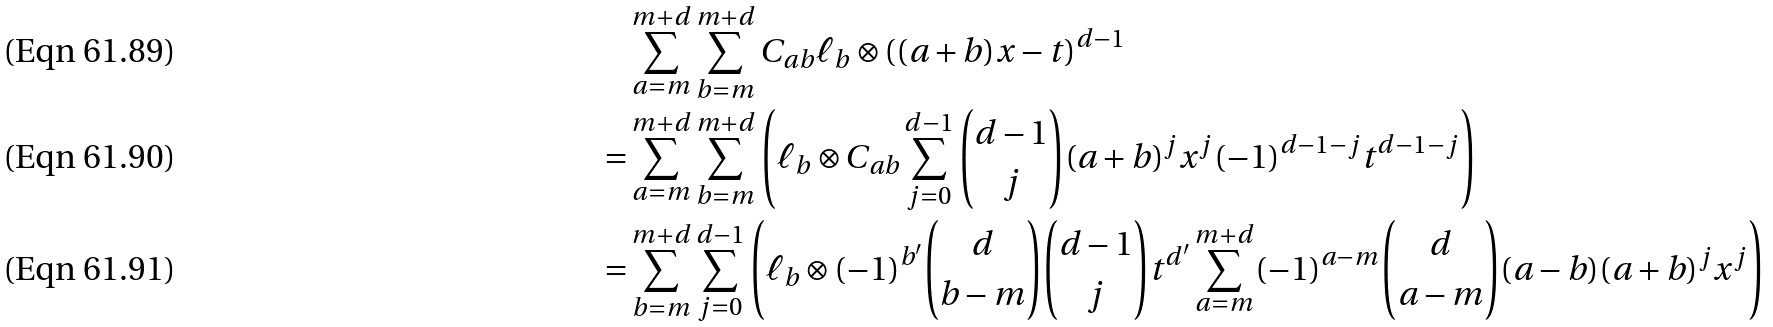Convert formula to latex. <formula><loc_0><loc_0><loc_500><loc_500>& \sum _ { a = m } ^ { m + d } \sum _ { b = m } ^ { m + d } C _ { a b } \ell _ { b } \otimes \left ( ( a + b ) x - t \right ) ^ { d - 1 } \\ = & \sum _ { a = m } ^ { m + d } \sum _ { b = m } ^ { m + d } \left ( \ell _ { b } \otimes C _ { a b } \sum _ { j = 0 } ^ { d - 1 } \binom { d - 1 } { j } ( a + b ) ^ { j } x ^ { j } ( - 1 ) ^ { d - 1 - j } t ^ { d - 1 - j } \right ) \\ = & \sum _ { b = m } ^ { m + d } \sum _ { j = 0 } ^ { d - 1 } \left ( \ell _ { b } \otimes ( - 1 ) ^ { b ^ { \prime } } \binom { d } { b - m } \binom { d - 1 } { j } t ^ { d ^ { \prime } } \sum _ { a = m } ^ { m + d } ( - 1 ) ^ { a - m } \binom { d } { a - m } ( a - b ) ( a + b ) ^ { j } x ^ { j } \right )</formula> 